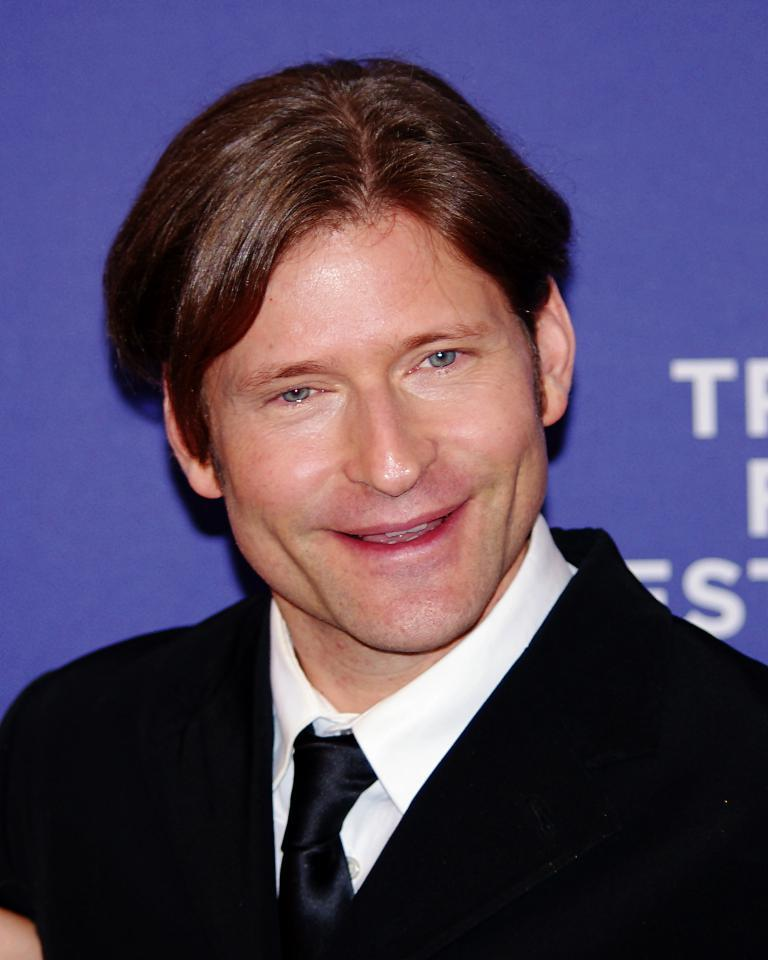Who is present in the image? There is a person in the image. What is the person wearing? The person is wearing a black suit. What is the person's facial expression? The person is smiling. What else can be seen in the image besides the person? There is a banner visible in the image. What type of hook can be seen on the person's leg in the image? There is no hook present on the person's leg in the image. Is the image taken during the night? The time of day is not mentioned in the provided facts, so it cannot be determined if the image was taken during the night. 